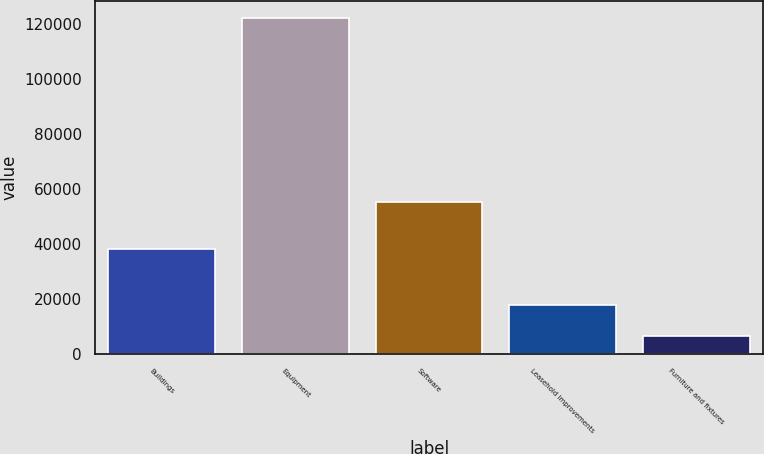Convert chart to OTSL. <chart><loc_0><loc_0><loc_500><loc_500><bar_chart><fcel>Buildings<fcel>Equipment<fcel>Software<fcel>Leasehold improvements<fcel>Furniture and fixtures<nl><fcel>38356<fcel>122200<fcel>55474<fcel>18092.5<fcel>6525<nl></chart> 